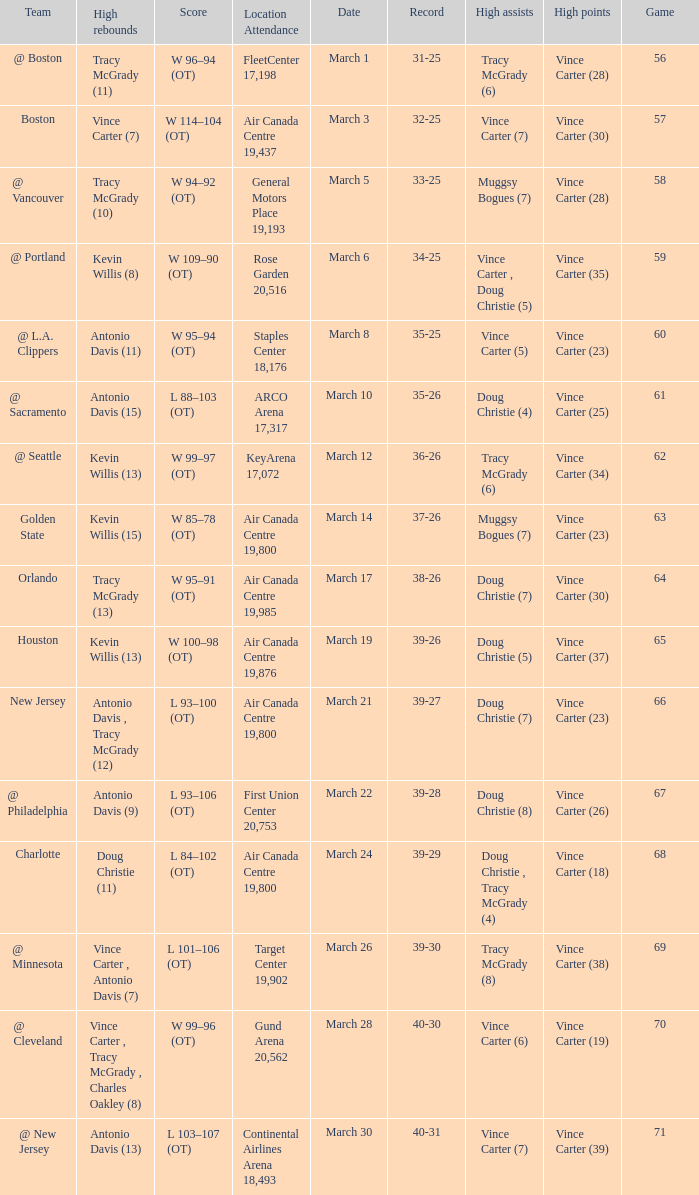Where did the team play and what was the attendance against new jersey? Air Canada Centre 19,800. 